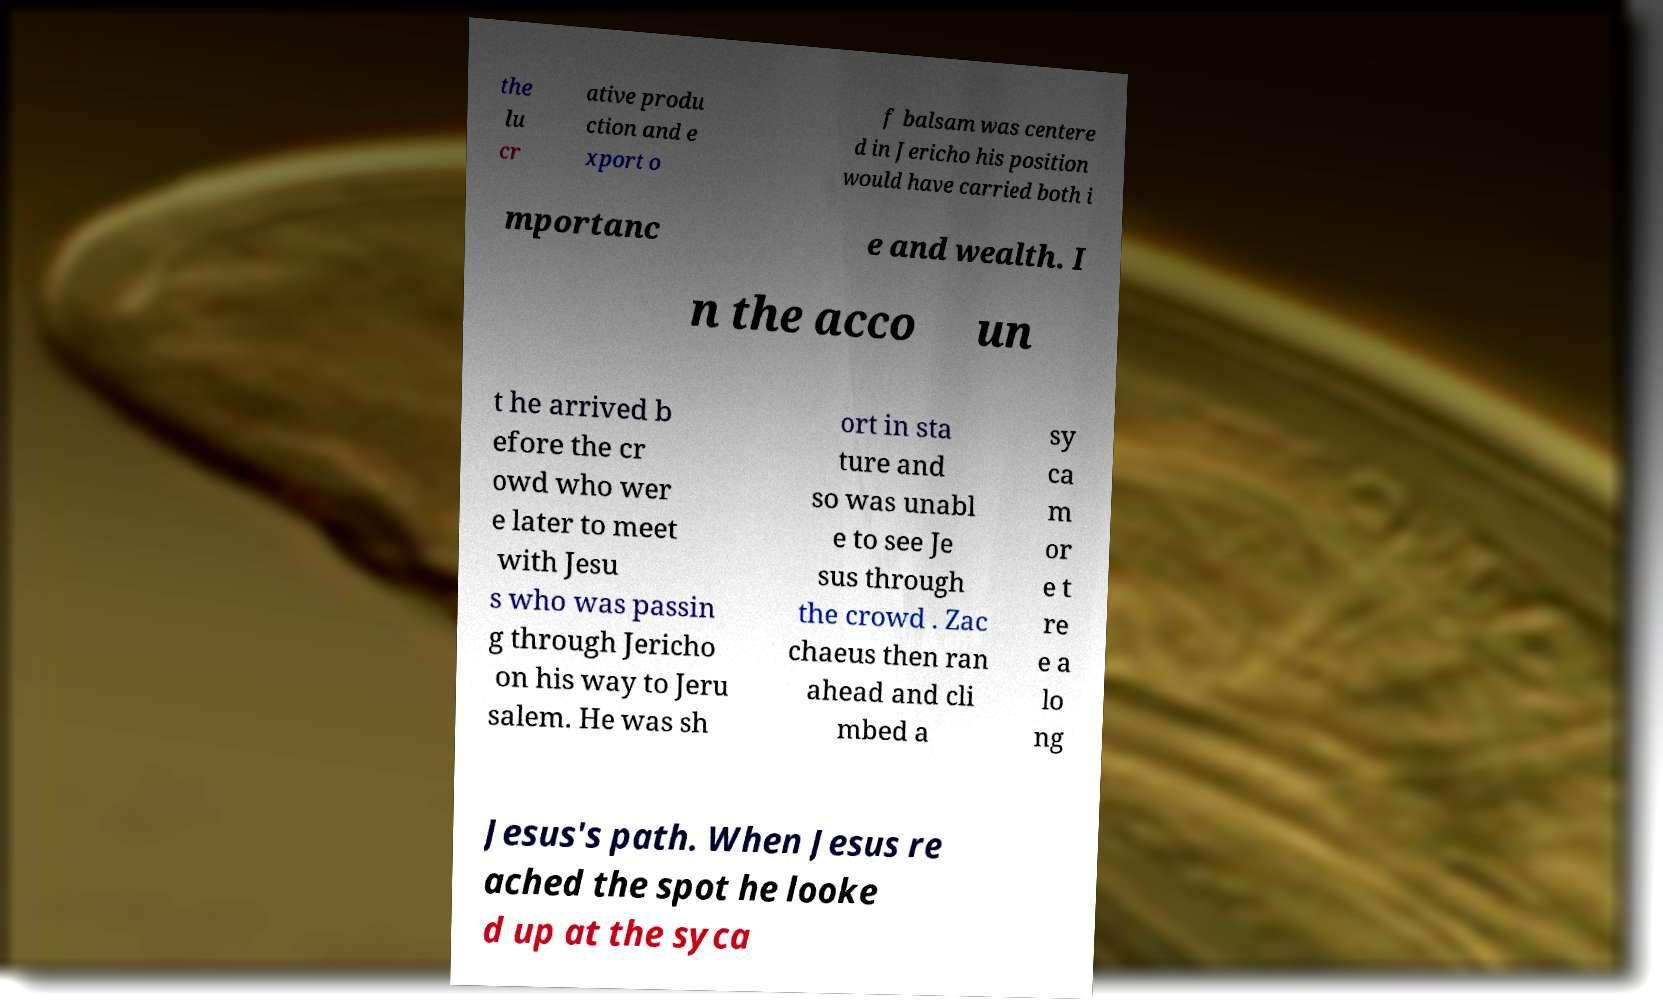For documentation purposes, I need the text within this image transcribed. Could you provide that? the lu cr ative produ ction and e xport o f balsam was centere d in Jericho his position would have carried both i mportanc e and wealth. I n the acco un t he arrived b efore the cr owd who wer e later to meet with Jesu s who was passin g through Jericho on his way to Jeru salem. He was sh ort in sta ture and so was unabl e to see Je sus through the crowd . Zac chaeus then ran ahead and cli mbed a sy ca m or e t re e a lo ng Jesus's path. When Jesus re ached the spot he looke d up at the syca 